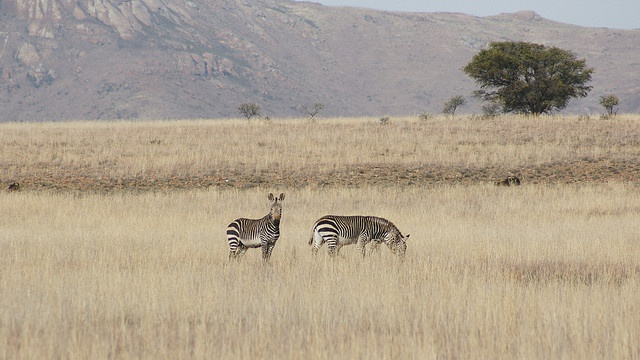Describe the objects in this image and their specific colors. I can see zebra in gray, tan, and black tones and zebra in gray, black, and tan tones in this image. 